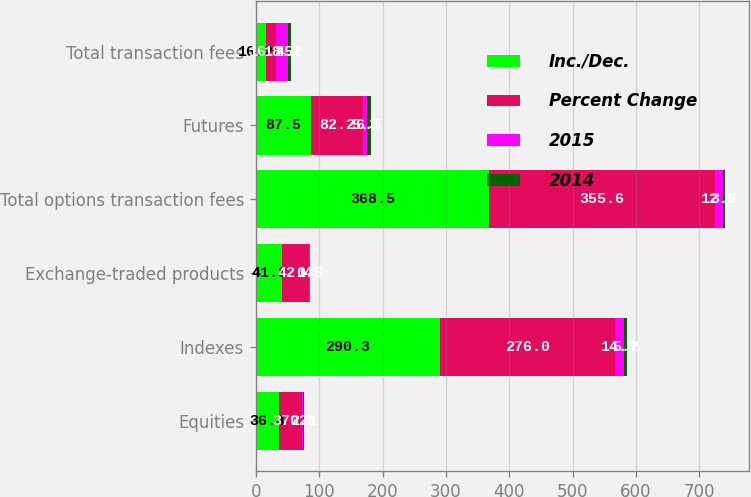<chart> <loc_0><loc_0><loc_500><loc_500><stacked_bar_chart><ecel><fcel>Equities<fcel>Indexes<fcel>Exchange-traded products<fcel>Total options transaction fees<fcel>Futures<fcel>Total transaction fees<nl><fcel>Inc./Dec.<fcel>36.4<fcel>290.3<fcel>41.8<fcel>368.5<fcel>87.5<fcel>16.25<nl><fcel>Percent Change<fcel>37.2<fcel>276<fcel>42.4<fcel>355.6<fcel>82.2<fcel>16.25<nl><fcel>2015<fcel>0.8<fcel>14.3<fcel>0.6<fcel>12.9<fcel>5.3<fcel>18.2<nl><fcel>2014<fcel>2.1<fcel>5.2<fcel>1.5<fcel>3.6<fcel>6.5<fcel>4.2<nl></chart> 